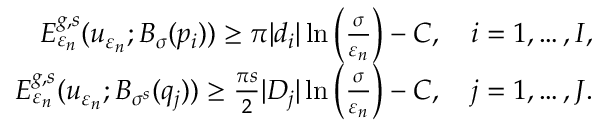<formula> <loc_0><loc_0><loc_500><loc_500>\begin{array} { r } { E _ { \varepsilon _ { n } } ^ { g , s } ( u _ { \varepsilon _ { n } } ; B _ { \sigma } ( p _ { i } ) ) \geq \pi | d _ { i } | \ln \left ( \frac { \sigma } { \varepsilon _ { n } } \right ) - C , \quad i = 1 , \dots , I , } \\ { E _ { \varepsilon _ { n } } ^ { g , s } ( u _ { \varepsilon _ { n } } ; B _ { \sigma ^ { s } } ( q _ { j } ) ) \geq \frac { \pi s } { 2 } | D _ { j } | \ln \left ( \frac { \sigma } { \varepsilon _ { n } } \right ) - C , \quad j = 1 , \dots , J . } \end{array}</formula> 